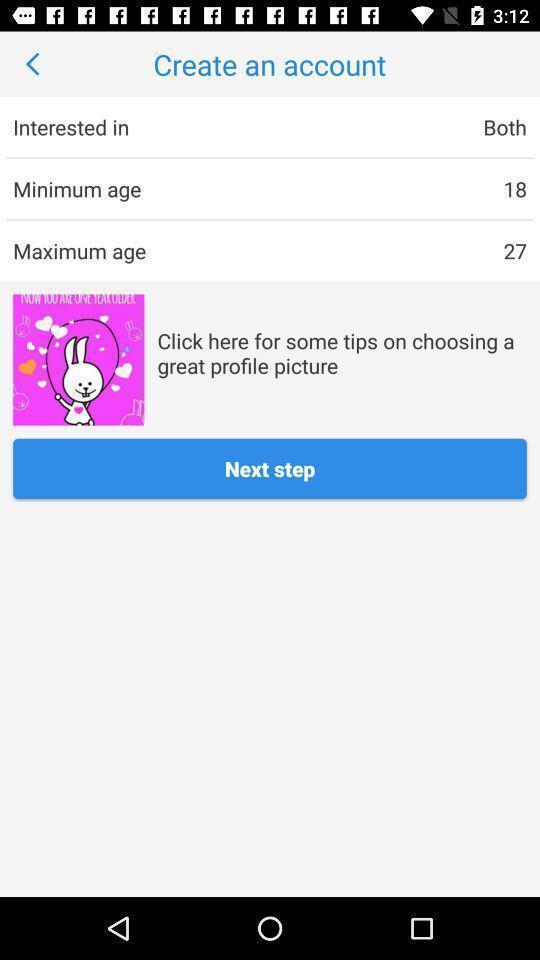Describe this image in words. Page showing the profile details in social app. 